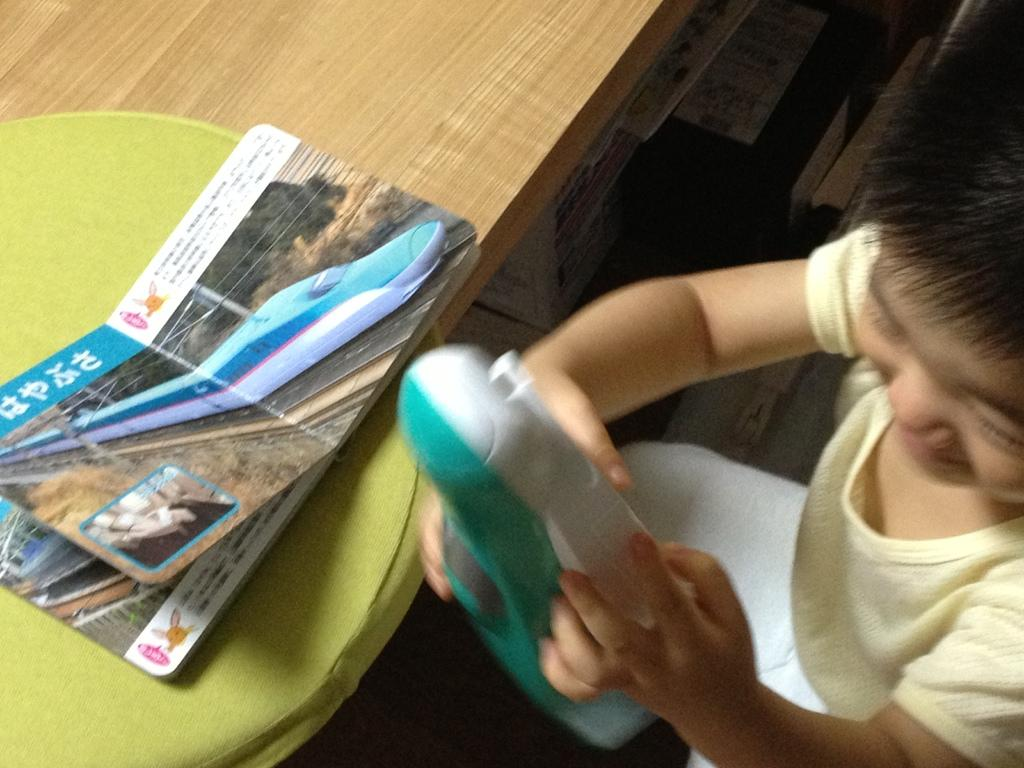What is the main subject of the image? The main subject of the image is a kid. What is the kid holding in the image? The kid is holding an object. Can you describe the location of the book in the image? The book is on a cushion, and the cushion is on a table. How many objects can be seen in the image? There are some objects in the image, but the exact number is not specified. Can you see a kitty playing with a quince in the image? No, there is no kitty or quince present in the image. 